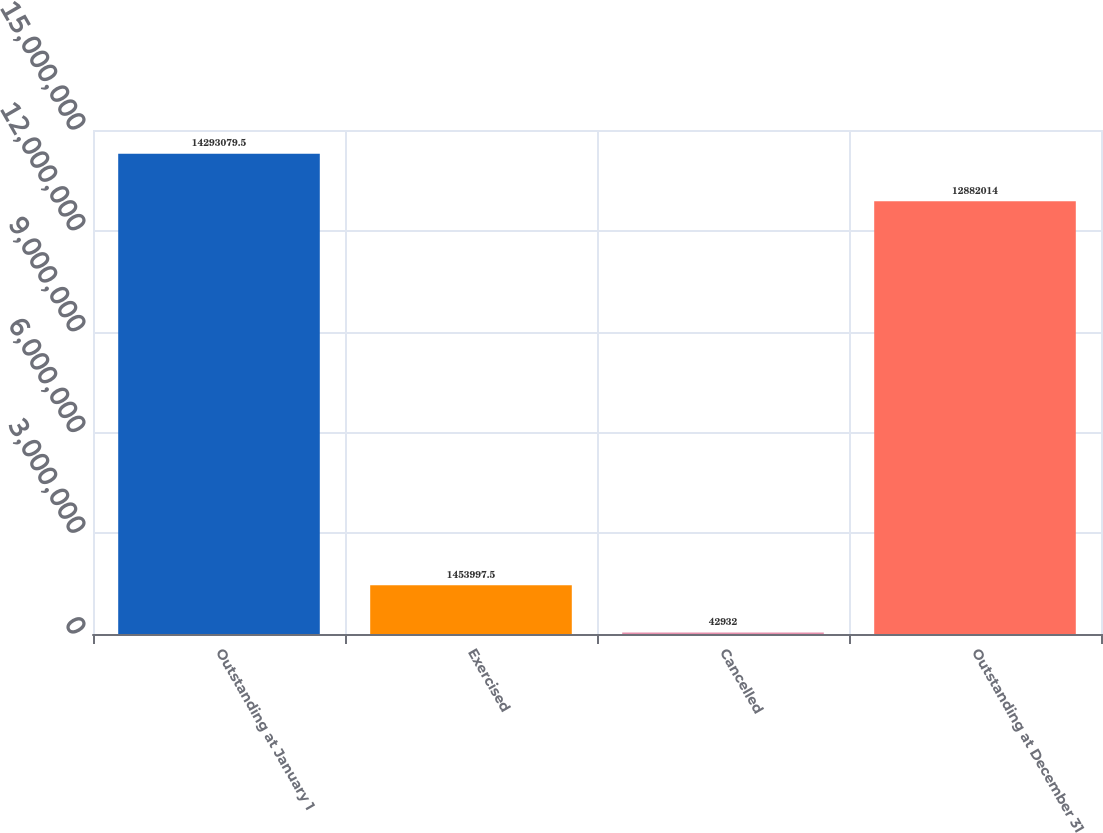<chart> <loc_0><loc_0><loc_500><loc_500><bar_chart><fcel>Outstanding at January 1<fcel>Exercised<fcel>Cancelled<fcel>Outstanding at December 31<nl><fcel>1.42931e+07<fcel>1.454e+06<fcel>42932<fcel>1.2882e+07<nl></chart> 